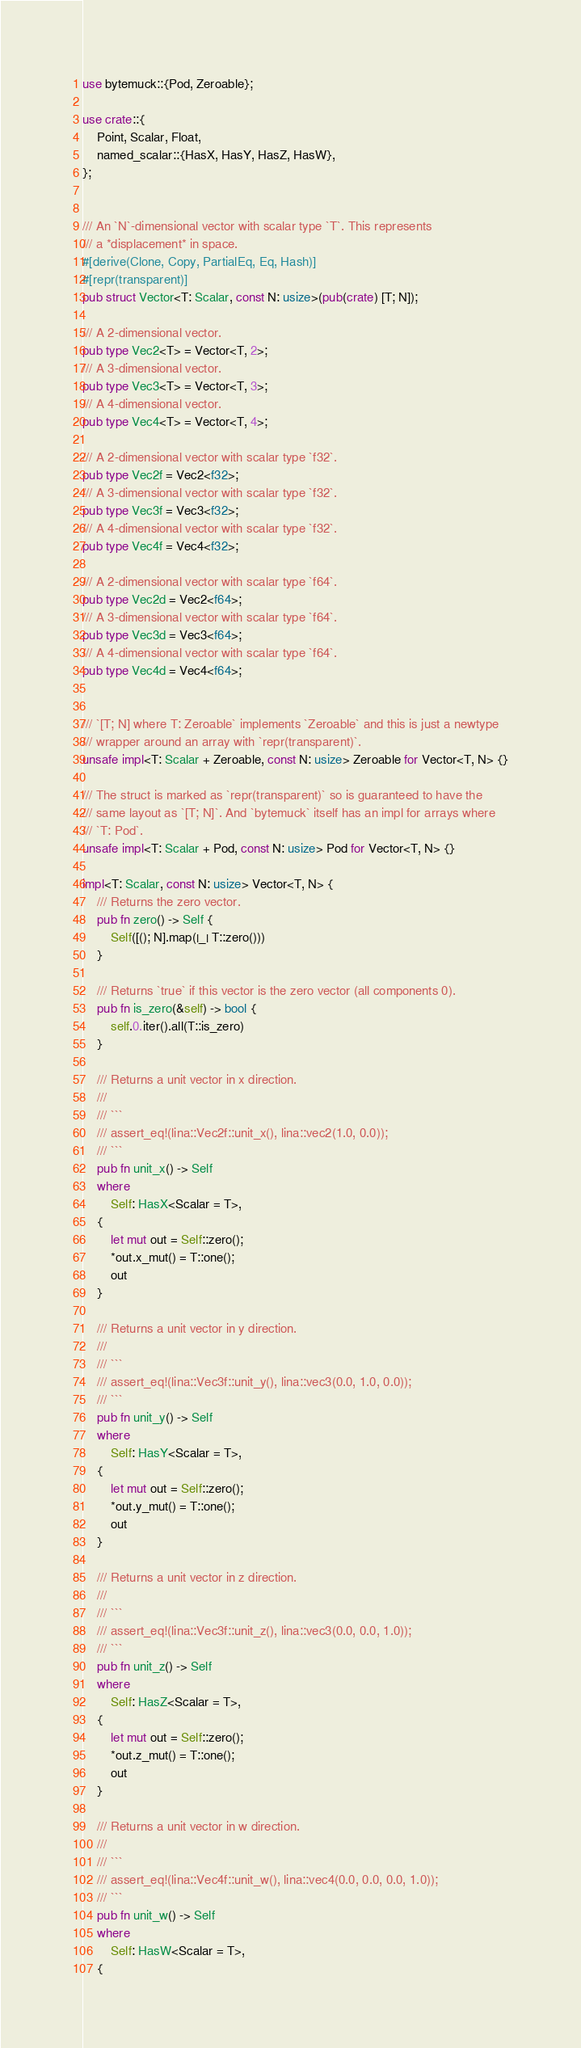<code> <loc_0><loc_0><loc_500><loc_500><_Rust_>use bytemuck::{Pod, Zeroable};

use crate::{
    Point, Scalar, Float,
    named_scalar::{HasX, HasY, HasZ, HasW},
};


/// An `N`-dimensional vector with scalar type `T`. This represents
/// a *displacement* in space.
#[derive(Clone, Copy, PartialEq, Eq, Hash)]
#[repr(transparent)]
pub struct Vector<T: Scalar, const N: usize>(pub(crate) [T; N]);

/// A 2-dimensional vector.
pub type Vec2<T> = Vector<T, 2>;
/// A 3-dimensional vector.
pub type Vec3<T> = Vector<T, 3>;
/// A 4-dimensional vector.
pub type Vec4<T> = Vector<T, 4>;

/// A 2-dimensional vector with scalar type `f32`.
pub type Vec2f = Vec2<f32>;
/// A 3-dimensional vector with scalar type `f32`.
pub type Vec3f = Vec3<f32>;
/// A 4-dimensional vector with scalar type `f32`.
pub type Vec4f = Vec4<f32>;

/// A 2-dimensional vector with scalar type `f64`.
pub type Vec2d = Vec2<f64>;
/// A 3-dimensional vector with scalar type `f64`.
pub type Vec3d = Vec3<f64>;
/// A 4-dimensional vector with scalar type `f64`.
pub type Vec4d = Vec4<f64>;


/// `[T; N] where T: Zeroable` implements `Zeroable` and this is just a newtype
/// wrapper around an array with `repr(transparent)`.
unsafe impl<T: Scalar + Zeroable, const N: usize> Zeroable for Vector<T, N> {}

/// The struct is marked as `repr(transparent)` so is guaranteed to have the
/// same layout as `[T; N]`. And `bytemuck` itself has an impl for arrays where
/// `T: Pod`.
unsafe impl<T: Scalar + Pod, const N: usize> Pod for Vector<T, N> {}

impl<T: Scalar, const N: usize> Vector<T, N> {
    /// Returns the zero vector.
    pub fn zero() -> Self {
        Self([(); N].map(|_| T::zero()))
    }

    /// Returns `true` if this vector is the zero vector (all components 0).
    pub fn is_zero(&self) -> bool {
        self.0.iter().all(T::is_zero)
    }

    /// Returns a unit vector in x direction.
    ///
    /// ```
    /// assert_eq!(lina::Vec2f::unit_x(), lina::vec2(1.0, 0.0));
    /// ```
    pub fn unit_x() -> Self
    where
        Self: HasX<Scalar = T>,
    {
        let mut out = Self::zero();
        *out.x_mut() = T::one();
        out
    }

    /// Returns a unit vector in y direction.
    ///
    /// ```
    /// assert_eq!(lina::Vec3f::unit_y(), lina::vec3(0.0, 1.0, 0.0));
    /// ```
    pub fn unit_y() -> Self
    where
        Self: HasY<Scalar = T>,
    {
        let mut out = Self::zero();
        *out.y_mut() = T::one();
        out
    }

    /// Returns a unit vector in z direction.
    ///
    /// ```
    /// assert_eq!(lina::Vec3f::unit_z(), lina::vec3(0.0, 0.0, 1.0));
    /// ```
    pub fn unit_z() -> Self
    where
        Self: HasZ<Scalar = T>,
    {
        let mut out = Self::zero();
        *out.z_mut() = T::one();
        out
    }

    /// Returns a unit vector in w direction.
    ///
    /// ```
    /// assert_eq!(lina::Vec4f::unit_w(), lina::vec4(0.0, 0.0, 0.0, 1.0));
    /// ```
    pub fn unit_w() -> Self
    where
        Self: HasW<Scalar = T>,
    {</code> 